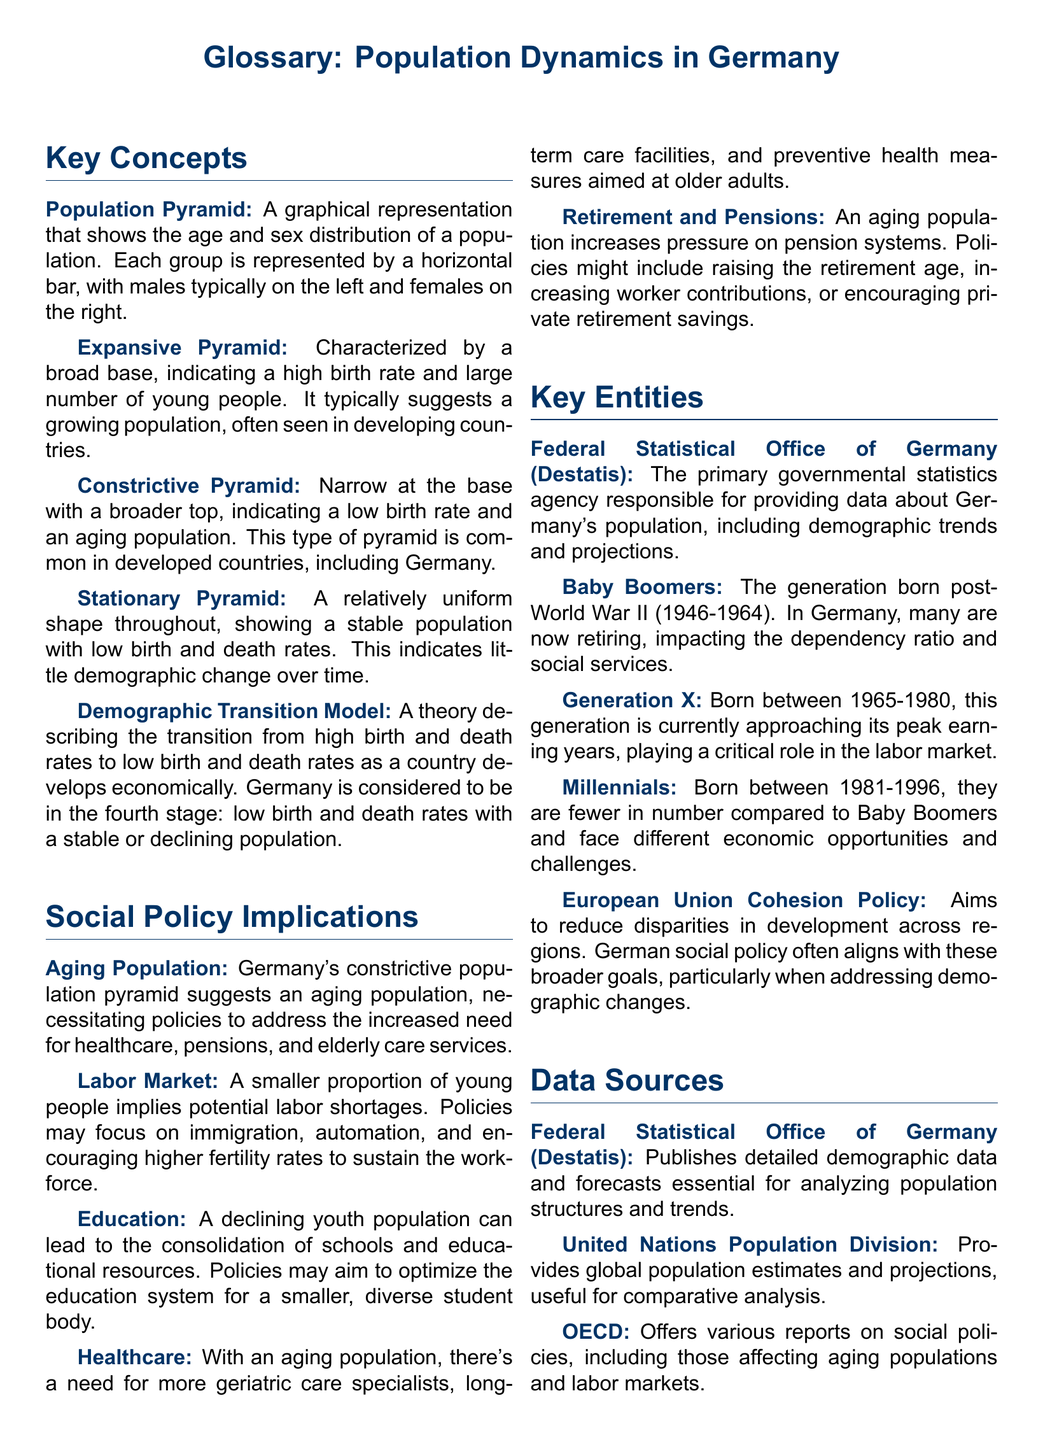What is a population pyramid? A population pyramid is a graphical representation that shows the age and sex distribution of a population.
Answer: A graphical representation What type of pyramid indicates a high birth rate? An expansive pyramid is characterized by a broad base, indicating a high birth rate and large number of young people.
Answer: Expansive pyramid What does a constrictive pyramid indicate about birth rates? A constrictive pyramid indicates a low birth rate and an aging population.
Answer: Low birth rate In which demographic transition model stage is Germany considered? Germany is considered to be in the fourth stage: low birth and death rates with a stable or declining population.
Answer: Fourth stage What key policy is suggested by Germany's aging population? Policies to address the increased need for healthcare, pensions, and elderly care services are suggested.
Answer: Healthcare, pensions, and elderly care services What challenge is associated with a smaller proportion of young people in the labor market? Potential labor shortages may arise from a smaller proportion of young people.
Answer: Labor shortages Which generation was born after World War II? The Baby Boomers is the generation born post-World War II.
Answer: Baby Boomers What agency provides demographic data for Germany? The Federal Statistical Office of Germany (Destatis) is the primary governmental statistics agency.
Answer: Federal Statistical Office of Germany (Destatis) What demographic trend is affecting the educational resources in Germany? A declining youth population can lead to the consolidation of schools and educational resources.
Answer: Consolidation of schools What does the European Union Cohesion Policy aim to address? The European Union Cohesion Policy aims to reduce disparities in development across regions.
Answer: Disparities in development 